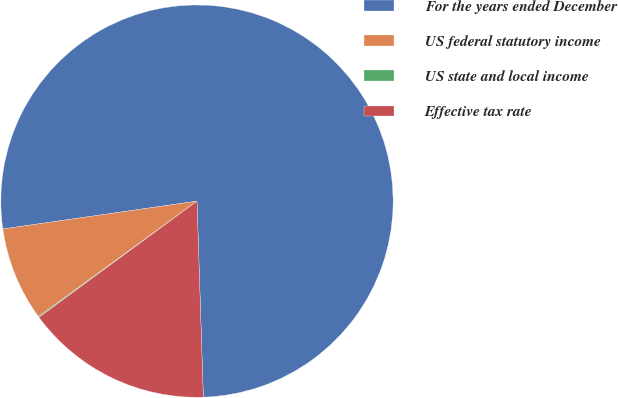Convert chart to OTSL. <chart><loc_0><loc_0><loc_500><loc_500><pie_chart><fcel>For the years ended December<fcel>US federal statutory income<fcel>US state and local income<fcel>Effective tax rate<nl><fcel>76.75%<fcel>7.75%<fcel>0.08%<fcel>15.42%<nl></chart> 